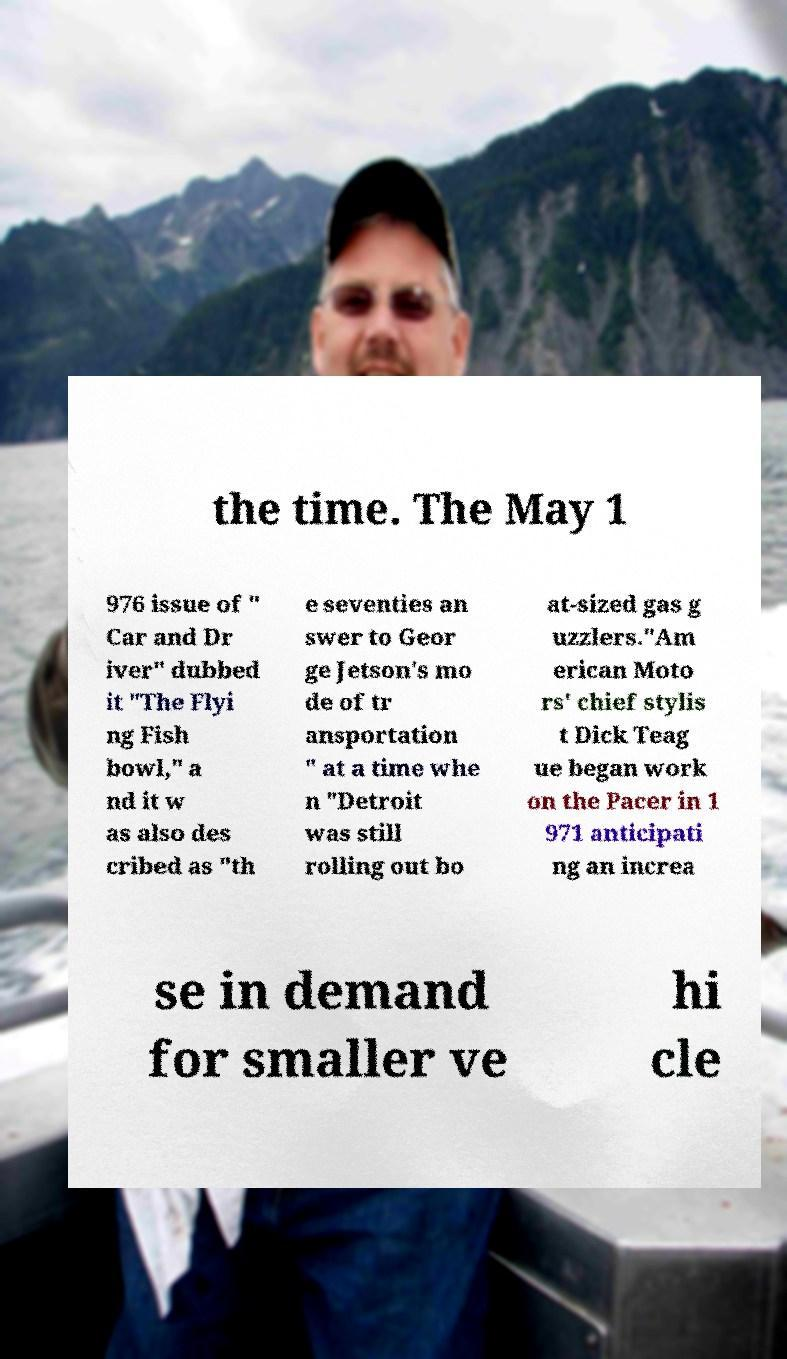What messages or text are displayed in this image? I need them in a readable, typed format. the time. The May 1 976 issue of " Car and Dr iver" dubbed it "The Flyi ng Fish bowl," a nd it w as also des cribed as "th e seventies an swer to Geor ge Jetson's mo de of tr ansportation " at a time whe n "Detroit was still rolling out bo at-sized gas g uzzlers."Am erican Moto rs' chief stylis t Dick Teag ue began work on the Pacer in 1 971 anticipati ng an increa se in demand for smaller ve hi cle 